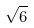Convert formula to latex. <formula><loc_0><loc_0><loc_500><loc_500>\sqrt { 6 }</formula> 